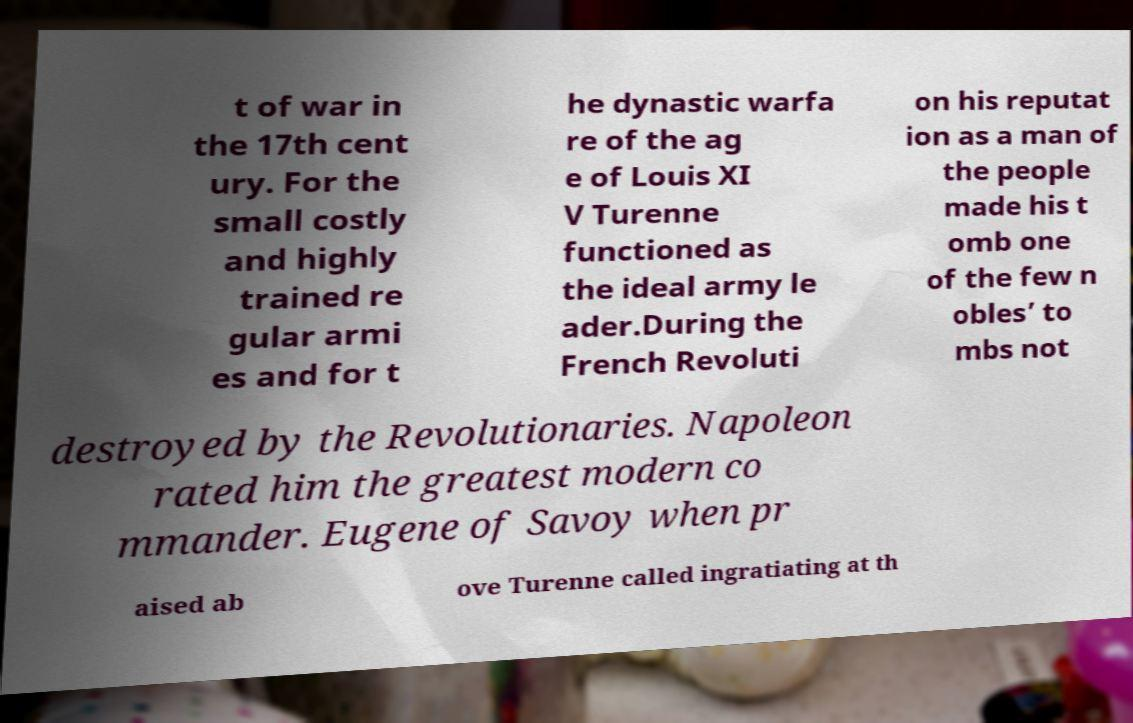There's text embedded in this image that I need extracted. Can you transcribe it verbatim? t of war in the 17th cent ury. For the small costly and highly trained re gular armi es and for t he dynastic warfa re of the ag e of Louis XI V Turenne functioned as the ideal army le ader.During the French Revoluti on his reputat ion as a man of the people made his t omb one of the few n obles’ to mbs not destroyed by the Revolutionaries. Napoleon rated him the greatest modern co mmander. Eugene of Savoy when pr aised ab ove Turenne called ingratiating at th 